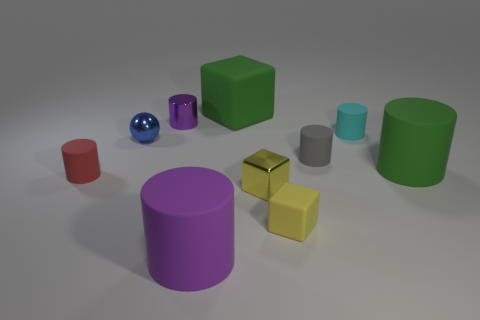Are there more small cylinders right of the tiny cyan object than tiny gray matte cylinders that are on the left side of the blue metallic ball?
Your answer should be very brief. No. There is a blue object that is the same size as the gray cylinder; what is its material?
Make the answer very short. Metal. How many big things are red cylinders or spheres?
Provide a succinct answer. 0. Is the purple metal object the same shape as the small gray thing?
Offer a terse response. Yes. How many metal objects are in front of the tiny red object and on the left side of the big purple object?
Your response must be concise. 0. Is there anything else of the same color as the ball?
Your answer should be very brief. No. What shape is the tiny purple object that is the same material as the small blue sphere?
Your answer should be compact. Cylinder. Does the green matte cube have the same size as the green rubber cylinder?
Your response must be concise. Yes. Is the material of the big green object right of the gray rubber cylinder the same as the large block?
Make the answer very short. Yes. Are there any other things that are the same material as the cyan object?
Provide a short and direct response. Yes. 